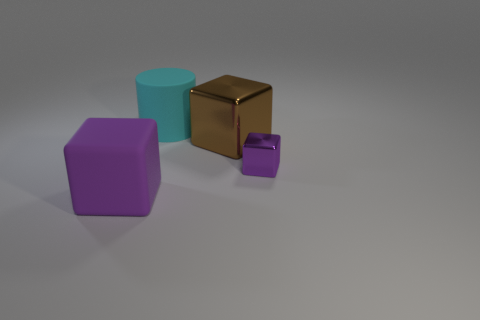There is a thing that is the same material as the big brown cube; what is its shape?
Your response must be concise. Cube. Is the number of cylinders that are to the right of the cyan rubber object greater than the number of tiny red shiny cylinders?
Make the answer very short. No. What number of small shiny things have the same color as the big matte block?
Your answer should be compact. 1. How many other objects are there of the same color as the big metallic block?
Keep it short and to the point. 0. Are there more small gray metallic spheres than brown shiny blocks?
Provide a short and direct response. No. What is the cyan thing made of?
Give a very brief answer. Rubber. Does the purple object that is to the right of the purple rubber object have the same size as the brown cube?
Your response must be concise. No. How big is the shiny thing behind the tiny object?
Your answer should be compact. Large. Are there any other things that have the same material as the cyan cylinder?
Keep it short and to the point. Yes. How many objects are there?
Give a very brief answer. 4. 